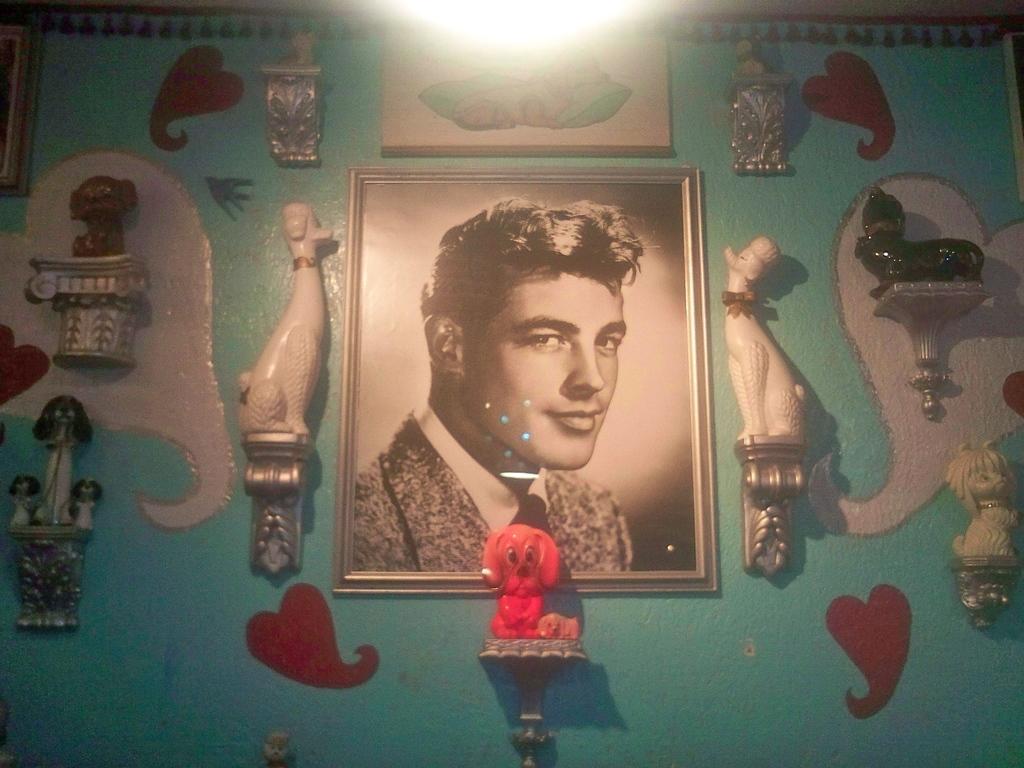Can you describe this image briefly? In the image in the center there is a wall. On the wall, we can see one photo frame, toys and some artwork. 